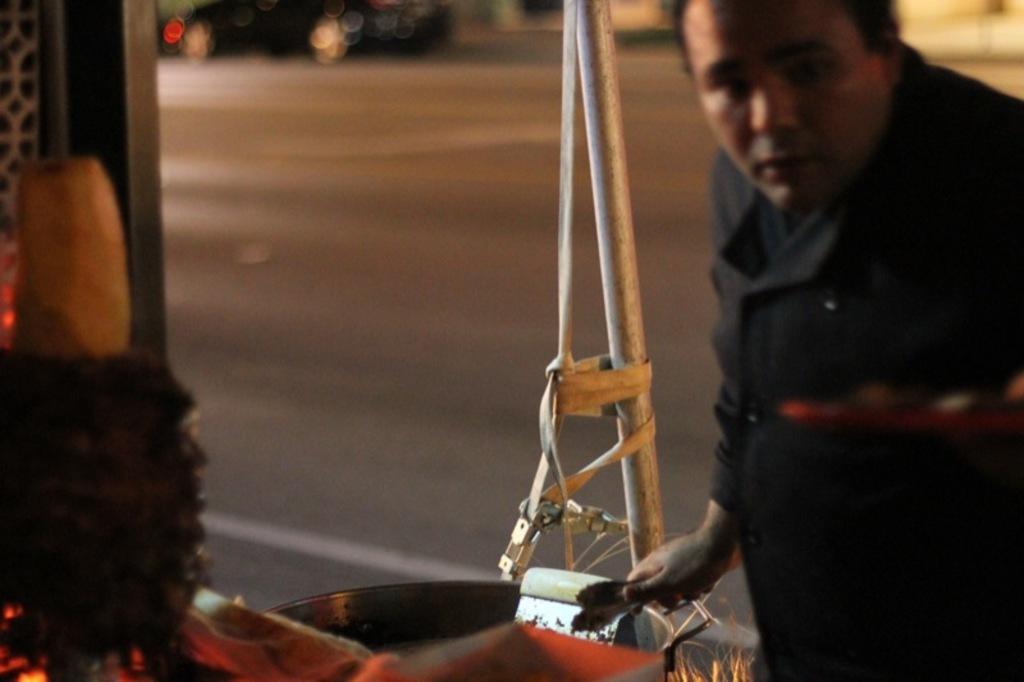In one or two sentences, can you explain what this image depicts? In this image we can see a person holding an object, in front of him there is an other object placed on a table, behind him there is a road. 